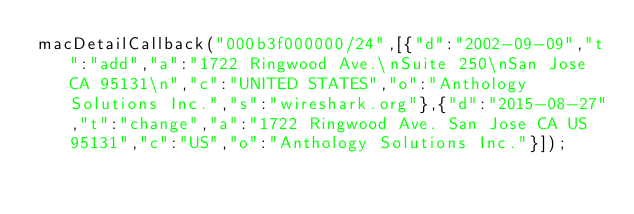<code> <loc_0><loc_0><loc_500><loc_500><_JavaScript_>macDetailCallback("000b3f000000/24",[{"d":"2002-09-09","t":"add","a":"1722 Ringwood Ave.\nSuite 250\nSan Jose CA 95131\n","c":"UNITED STATES","o":"Anthology Solutions Inc.","s":"wireshark.org"},{"d":"2015-08-27","t":"change","a":"1722 Ringwood Ave. San Jose CA US 95131","c":"US","o":"Anthology Solutions Inc."}]);
</code> 